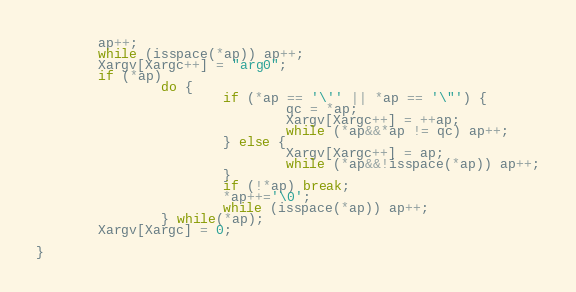Convert code to text. <code><loc_0><loc_0><loc_500><loc_500><_C_>        ap++;
        while (isspace(*ap)) ap++;
        Xargv[Xargc++] = "arg0";
        if (*ap)
                do {
                        if (*ap == '\'' || *ap == '\"') {
                                qc = *ap;
                                Xargv[Xargc++] = ++ap;
                                while (*ap&&*ap != qc) ap++;
                        } else {
                                Xargv[Xargc++] = ap;
                                while (*ap&&!isspace(*ap)) ap++;
                        }
                        if (!*ap) break;
                        *ap++='\0';
                        while (isspace(*ap)) ap++;
                } while(*ap);
        Xargv[Xargc] = 0;

}

</code> 